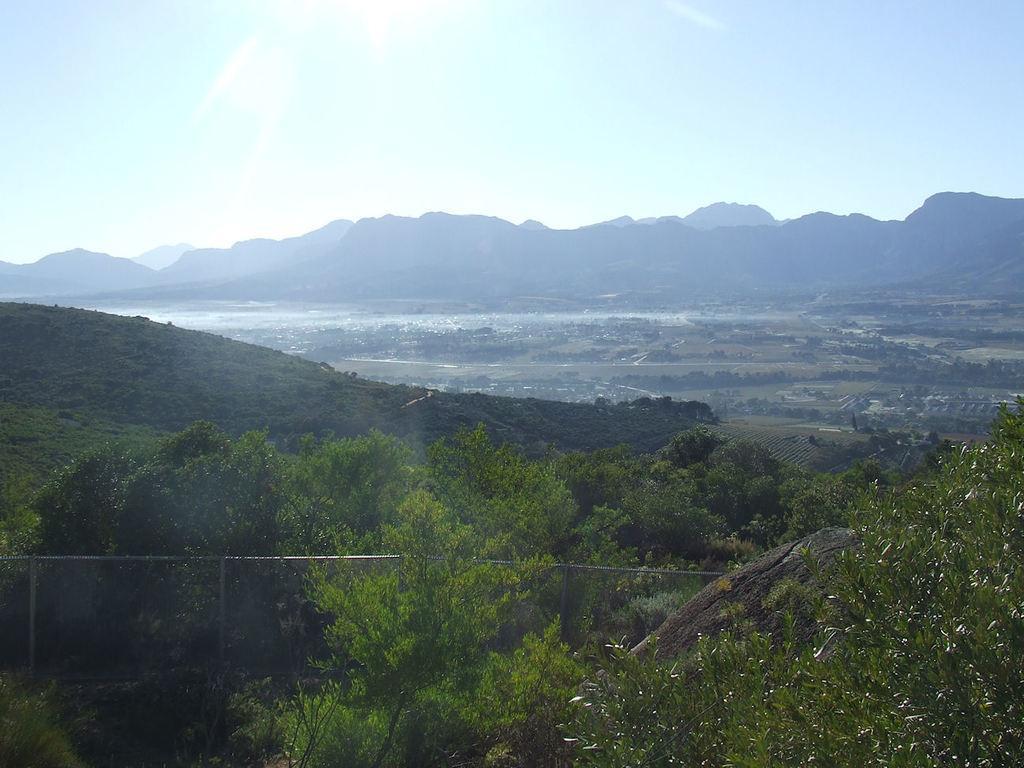Describe this image in one or two sentences. This picture is clicked outside the city. In the foreground we can see the trees and some metal rods. In the background there is a sky, a water body and the hills and many other objects. 